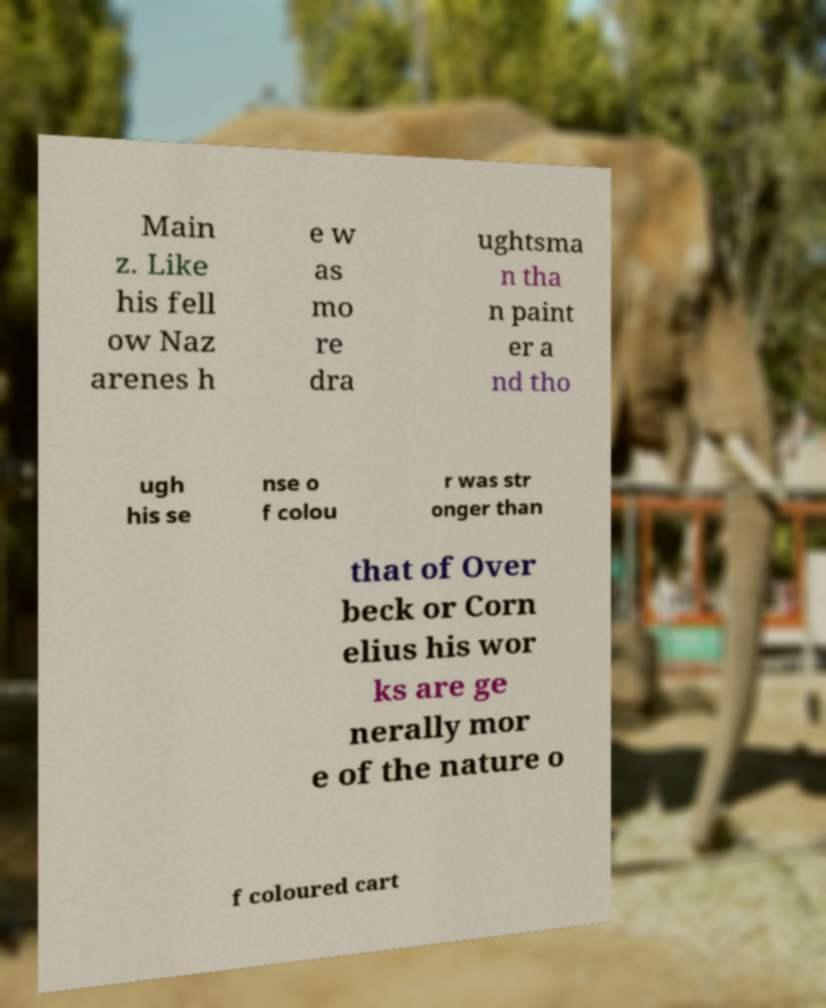Could you extract and type out the text from this image? Main z. Like his fell ow Naz arenes h e w as mo re dra ughtsma n tha n paint er a nd tho ugh his se nse o f colou r was str onger than that of Over beck or Corn elius his wor ks are ge nerally mor e of the nature o f coloured cart 